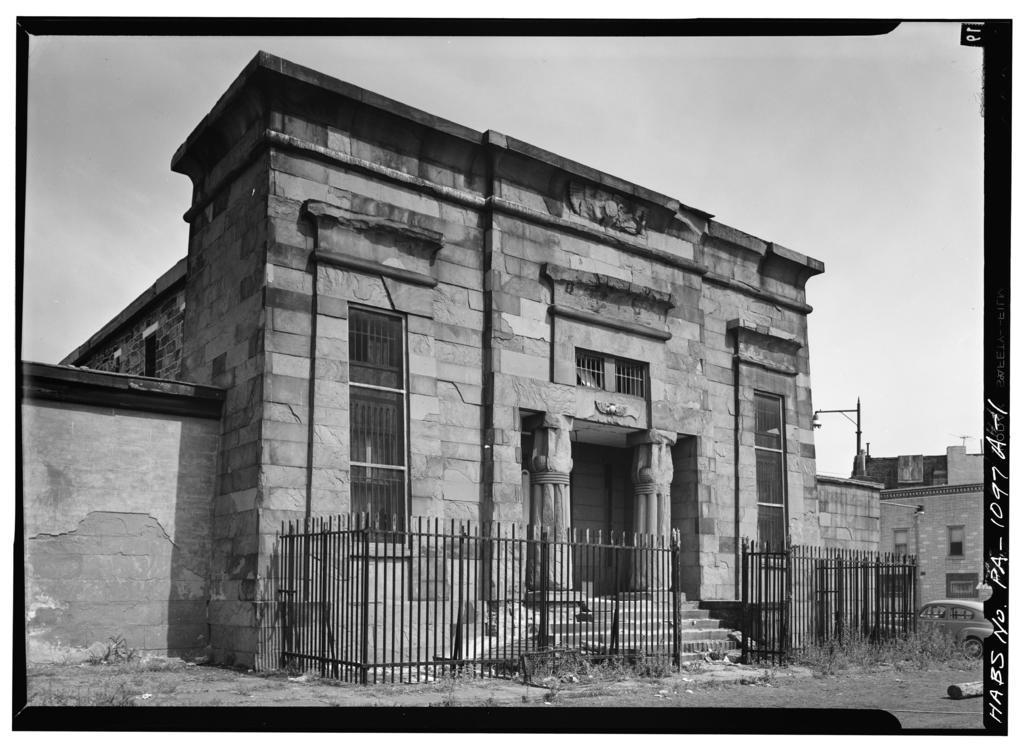Describe this image in one or two sentences. This is a black and white image. In the center of the image we can see building and fencing. In the background there are clouds and sky. 